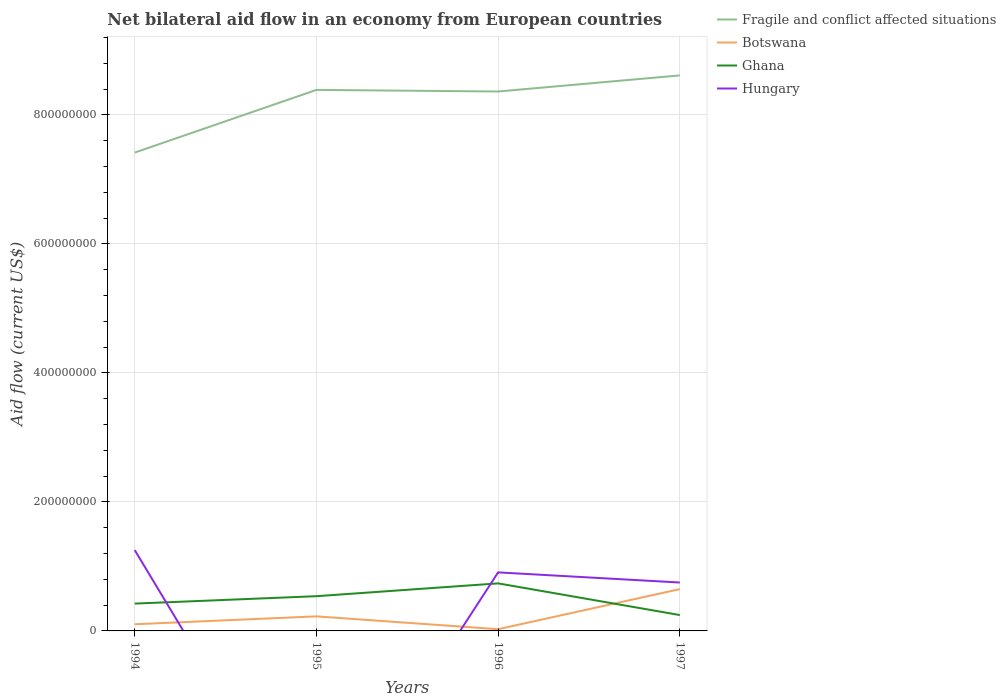How many different coloured lines are there?
Provide a short and direct response. 4. Across all years, what is the maximum net bilateral aid flow in Hungary?
Offer a very short reply. 0. What is the total net bilateral aid flow in Botswana in the graph?
Keep it short and to the point. -1.22e+07. What is the difference between the highest and the second highest net bilateral aid flow in Ghana?
Your response must be concise. 4.91e+07. What is the difference between the highest and the lowest net bilateral aid flow in Hungary?
Offer a very short reply. 3. Is the net bilateral aid flow in Ghana strictly greater than the net bilateral aid flow in Hungary over the years?
Offer a very short reply. No. How many years are there in the graph?
Give a very brief answer. 4. Are the values on the major ticks of Y-axis written in scientific E-notation?
Provide a succinct answer. No. Does the graph contain grids?
Keep it short and to the point. Yes. What is the title of the graph?
Your response must be concise. Net bilateral aid flow in an economy from European countries. Does "Peru" appear as one of the legend labels in the graph?
Make the answer very short. No. What is the label or title of the Y-axis?
Your response must be concise. Aid flow (current US$). What is the Aid flow (current US$) in Fragile and conflict affected situations in 1994?
Provide a succinct answer. 7.42e+08. What is the Aid flow (current US$) of Botswana in 1994?
Ensure brevity in your answer.  1.03e+07. What is the Aid flow (current US$) of Ghana in 1994?
Ensure brevity in your answer.  4.24e+07. What is the Aid flow (current US$) of Hungary in 1994?
Ensure brevity in your answer.  1.25e+08. What is the Aid flow (current US$) in Fragile and conflict affected situations in 1995?
Provide a succinct answer. 8.39e+08. What is the Aid flow (current US$) of Botswana in 1995?
Offer a very short reply. 2.26e+07. What is the Aid flow (current US$) in Ghana in 1995?
Your answer should be compact. 5.38e+07. What is the Aid flow (current US$) in Fragile and conflict affected situations in 1996?
Provide a short and direct response. 8.36e+08. What is the Aid flow (current US$) in Botswana in 1996?
Provide a succinct answer. 2.67e+06. What is the Aid flow (current US$) in Ghana in 1996?
Provide a short and direct response. 7.37e+07. What is the Aid flow (current US$) of Hungary in 1996?
Provide a short and direct response. 9.08e+07. What is the Aid flow (current US$) of Fragile and conflict affected situations in 1997?
Provide a succinct answer. 8.61e+08. What is the Aid flow (current US$) in Botswana in 1997?
Offer a terse response. 6.48e+07. What is the Aid flow (current US$) in Ghana in 1997?
Ensure brevity in your answer.  2.46e+07. What is the Aid flow (current US$) in Hungary in 1997?
Keep it short and to the point. 7.50e+07. Across all years, what is the maximum Aid flow (current US$) of Fragile and conflict affected situations?
Offer a very short reply. 8.61e+08. Across all years, what is the maximum Aid flow (current US$) in Botswana?
Provide a short and direct response. 6.48e+07. Across all years, what is the maximum Aid flow (current US$) of Ghana?
Provide a short and direct response. 7.37e+07. Across all years, what is the maximum Aid flow (current US$) in Hungary?
Offer a very short reply. 1.25e+08. Across all years, what is the minimum Aid flow (current US$) in Fragile and conflict affected situations?
Your answer should be very brief. 7.42e+08. Across all years, what is the minimum Aid flow (current US$) of Botswana?
Your answer should be compact. 2.67e+06. Across all years, what is the minimum Aid flow (current US$) in Ghana?
Your answer should be very brief. 2.46e+07. What is the total Aid flow (current US$) in Fragile and conflict affected situations in the graph?
Make the answer very short. 3.28e+09. What is the total Aid flow (current US$) of Botswana in the graph?
Your answer should be compact. 1.00e+08. What is the total Aid flow (current US$) of Ghana in the graph?
Provide a succinct answer. 1.94e+08. What is the total Aid flow (current US$) of Hungary in the graph?
Your answer should be very brief. 2.91e+08. What is the difference between the Aid flow (current US$) of Fragile and conflict affected situations in 1994 and that in 1995?
Keep it short and to the point. -9.72e+07. What is the difference between the Aid flow (current US$) in Botswana in 1994 and that in 1995?
Your response must be concise. -1.22e+07. What is the difference between the Aid flow (current US$) in Ghana in 1994 and that in 1995?
Offer a very short reply. -1.15e+07. What is the difference between the Aid flow (current US$) of Fragile and conflict affected situations in 1994 and that in 1996?
Provide a short and direct response. -9.47e+07. What is the difference between the Aid flow (current US$) in Botswana in 1994 and that in 1996?
Your answer should be compact. 7.67e+06. What is the difference between the Aid flow (current US$) of Ghana in 1994 and that in 1996?
Offer a very short reply. -3.13e+07. What is the difference between the Aid flow (current US$) of Hungary in 1994 and that in 1996?
Provide a short and direct response. 3.45e+07. What is the difference between the Aid flow (current US$) of Fragile and conflict affected situations in 1994 and that in 1997?
Offer a very short reply. -1.20e+08. What is the difference between the Aid flow (current US$) of Botswana in 1994 and that in 1997?
Your response must be concise. -5.44e+07. What is the difference between the Aid flow (current US$) in Ghana in 1994 and that in 1997?
Make the answer very short. 1.78e+07. What is the difference between the Aid flow (current US$) in Hungary in 1994 and that in 1997?
Your answer should be very brief. 5.02e+07. What is the difference between the Aid flow (current US$) of Fragile and conflict affected situations in 1995 and that in 1996?
Provide a short and direct response. 2.49e+06. What is the difference between the Aid flow (current US$) of Botswana in 1995 and that in 1996?
Provide a succinct answer. 1.99e+07. What is the difference between the Aid flow (current US$) in Ghana in 1995 and that in 1996?
Keep it short and to the point. -1.99e+07. What is the difference between the Aid flow (current US$) in Fragile and conflict affected situations in 1995 and that in 1997?
Offer a very short reply. -2.24e+07. What is the difference between the Aid flow (current US$) in Botswana in 1995 and that in 1997?
Offer a very short reply. -4.22e+07. What is the difference between the Aid flow (current US$) of Ghana in 1995 and that in 1997?
Your answer should be compact. 2.92e+07. What is the difference between the Aid flow (current US$) of Fragile and conflict affected situations in 1996 and that in 1997?
Provide a short and direct response. -2.49e+07. What is the difference between the Aid flow (current US$) in Botswana in 1996 and that in 1997?
Offer a terse response. -6.21e+07. What is the difference between the Aid flow (current US$) in Ghana in 1996 and that in 1997?
Offer a terse response. 4.91e+07. What is the difference between the Aid flow (current US$) in Hungary in 1996 and that in 1997?
Provide a short and direct response. 1.57e+07. What is the difference between the Aid flow (current US$) of Fragile and conflict affected situations in 1994 and the Aid flow (current US$) of Botswana in 1995?
Keep it short and to the point. 7.19e+08. What is the difference between the Aid flow (current US$) of Fragile and conflict affected situations in 1994 and the Aid flow (current US$) of Ghana in 1995?
Provide a short and direct response. 6.88e+08. What is the difference between the Aid flow (current US$) of Botswana in 1994 and the Aid flow (current US$) of Ghana in 1995?
Provide a short and direct response. -4.35e+07. What is the difference between the Aid flow (current US$) in Fragile and conflict affected situations in 1994 and the Aid flow (current US$) in Botswana in 1996?
Provide a succinct answer. 7.39e+08. What is the difference between the Aid flow (current US$) in Fragile and conflict affected situations in 1994 and the Aid flow (current US$) in Ghana in 1996?
Give a very brief answer. 6.68e+08. What is the difference between the Aid flow (current US$) of Fragile and conflict affected situations in 1994 and the Aid flow (current US$) of Hungary in 1996?
Provide a succinct answer. 6.51e+08. What is the difference between the Aid flow (current US$) of Botswana in 1994 and the Aid flow (current US$) of Ghana in 1996?
Provide a short and direct response. -6.34e+07. What is the difference between the Aid flow (current US$) of Botswana in 1994 and the Aid flow (current US$) of Hungary in 1996?
Ensure brevity in your answer.  -8.04e+07. What is the difference between the Aid flow (current US$) of Ghana in 1994 and the Aid flow (current US$) of Hungary in 1996?
Offer a very short reply. -4.84e+07. What is the difference between the Aid flow (current US$) of Fragile and conflict affected situations in 1994 and the Aid flow (current US$) of Botswana in 1997?
Give a very brief answer. 6.77e+08. What is the difference between the Aid flow (current US$) of Fragile and conflict affected situations in 1994 and the Aid flow (current US$) of Ghana in 1997?
Your response must be concise. 7.17e+08. What is the difference between the Aid flow (current US$) of Fragile and conflict affected situations in 1994 and the Aid flow (current US$) of Hungary in 1997?
Provide a short and direct response. 6.67e+08. What is the difference between the Aid flow (current US$) in Botswana in 1994 and the Aid flow (current US$) in Ghana in 1997?
Keep it short and to the point. -1.42e+07. What is the difference between the Aid flow (current US$) of Botswana in 1994 and the Aid flow (current US$) of Hungary in 1997?
Your answer should be compact. -6.47e+07. What is the difference between the Aid flow (current US$) in Ghana in 1994 and the Aid flow (current US$) in Hungary in 1997?
Offer a terse response. -3.27e+07. What is the difference between the Aid flow (current US$) in Fragile and conflict affected situations in 1995 and the Aid flow (current US$) in Botswana in 1996?
Ensure brevity in your answer.  8.36e+08. What is the difference between the Aid flow (current US$) in Fragile and conflict affected situations in 1995 and the Aid flow (current US$) in Ghana in 1996?
Offer a very short reply. 7.65e+08. What is the difference between the Aid flow (current US$) of Fragile and conflict affected situations in 1995 and the Aid flow (current US$) of Hungary in 1996?
Your response must be concise. 7.48e+08. What is the difference between the Aid flow (current US$) in Botswana in 1995 and the Aid flow (current US$) in Ghana in 1996?
Your response must be concise. -5.11e+07. What is the difference between the Aid flow (current US$) in Botswana in 1995 and the Aid flow (current US$) in Hungary in 1996?
Ensure brevity in your answer.  -6.82e+07. What is the difference between the Aid flow (current US$) of Ghana in 1995 and the Aid flow (current US$) of Hungary in 1996?
Your response must be concise. -3.69e+07. What is the difference between the Aid flow (current US$) of Fragile and conflict affected situations in 1995 and the Aid flow (current US$) of Botswana in 1997?
Make the answer very short. 7.74e+08. What is the difference between the Aid flow (current US$) of Fragile and conflict affected situations in 1995 and the Aid flow (current US$) of Ghana in 1997?
Provide a short and direct response. 8.14e+08. What is the difference between the Aid flow (current US$) in Fragile and conflict affected situations in 1995 and the Aid flow (current US$) in Hungary in 1997?
Offer a terse response. 7.64e+08. What is the difference between the Aid flow (current US$) of Botswana in 1995 and the Aid flow (current US$) of Ghana in 1997?
Ensure brevity in your answer.  -2.01e+06. What is the difference between the Aid flow (current US$) in Botswana in 1995 and the Aid flow (current US$) in Hungary in 1997?
Offer a very short reply. -5.25e+07. What is the difference between the Aid flow (current US$) in Ghana in 1995 and the Aid flow (current US$) in Hungary in 1997?
Offer a very short reply. -2.12e+07. What is the difference between the Aid flow (current US$) in Fragile and conflict affected situations in 1996 and the Aid flow (current US$) in Botswana in 1997?
Your answer should be compact. 7.71e+08. What is the difference between the Aid flow (current US$) in Fragile and conflict affected situations in 1996 and the Aid flow (current US$) in Ghana in 1997?
Offer a terse response. 8.12e+08. What is the difference between the Aid flow (current US$) of Fragile and conflict affected situations in 1996 and the Aid flow (current US$) of Hungary in 1997?
Offer a terse response. 7.61e+08. What is the difference between the Aid flow (current US$) of Botswana in 1996 and the Aid flow (current US$) of Ghana in 1997?
Keep it short and to the point. -2.19e+07. What is the difference between the Aid flow (current US$) of Botswana in 1996 and the Aid flow (current US$) of Hungary in 1997?
Offer a terse response. -7.24e+07. What is the difference between the Aid flow (current US$) of Ghana in 1996 and the Aid flow (current US$) of Hungary in 1997?
Ensure brevity in your answer.  -1.35e+06. What is the average Aid flow (current US$) in Fragile and conflict affected situations per year?
Offer a very short reply. 8.19e+08. What is the average Aid flow (current US$) of Botswana per year?
Make the answer very short. 2.51e+07. What is the average Aid flow (current US$) in Ghana per year?
Your response must be concise. 4.86e+07. What is the average Aid flow (current US$) of Hungary per year?
Your answer should be very brief. 7.28e+07. In the year 1994, what is the difference between the Aid flow (current US$) in Fragile and conflict affected situations and Aid flow (current US$) in Botswana?
Give a very brief answer. 7.31e+08. In the year 1994, what is the difference between the Aid flow (current US$) of Fragile and conflict affected situations and Aid flow (current US$) of Ghana?
Give a very brief answer. 6.99e+08. In the year 1994, what is the difference between the Aid flow (current US$) in Fragile and conflict affected situations and Aid flow (current US$) in Hungary?
Give a very brief answer. 6.16e+08. In the year 1994, what is the difference between the Aid flow (current US$) in Botswana and Aid flow (current US$) in Ghana?
Offer a terse response. -3.20e+07. In the year 1994, what is the difference between the Aid flow (current US$) of Botswana and Aid flow (current US$) of Hungary?
Ensure brevity in your answer.  -1.15e+08. In the year 1994, what is the difference between the Aid flow (current US$) of Ghana and Aid flow (current US$) of Hungary?
Offer a very short reply. -8.29e+07. In the year 1995, what is the difference between the Aid flow (current US$) in Fragile and conflict affected situations and Aid flow (current US$) in Botswana?
Your answer should be very brief. 8.16e+08. In the year 1995, what is the difference between the Aid flow (current US$) of Fragile and conflict affected situations and Aid flow (current US$) of Ghana?
Your answer should be very brief. 7.85e+08. In the year 1995, what is the difference between the Aid flow (current US$) in Botswana and Aid flow (current US$) in Ghana?
Offer a terse response. -3.13e+07. In the year 1996, what is the difference between the Aid flow (current US$) of Fragile and conflict affected situations and Aid flow (current US$) of Botswana?
Give a very brief answer. 8.34e+08. In the year 1996, what is the difference between the Aid flow (current US$) of Fragile and conflict affected situations and Aid flow (current US$) of Ghana?
Your answer should be very brief. 7.63e+08. In the year 1996, what is the difference between the Aid flow (current US$) of Fragile and conflict affected situations and Aid flow (current US$) of Hungary?
Your response must be concise. 7.45e+08. In the year 1996, what is the difference between the Aid flow (current US$) in Botswana and Aid flow (current US$) in Ghana?
Your response must be concise. -7.10e+07. In the year 1996, what is the difference between the Aid flow (current US$) in Botswana and Aid flow (current US$) in Hungary?
Your response must be concise. -8.81e+07. In the year 1996, what is the difference between the Aid flow (current US$) of Ghana and Aid flow (current US$) of Hungary?
Ensure brevity in your answer.  -1.70e+07. In the year 1997, what is the difference between the Aid flow (current US$) in Fragile and conflict affected situations and Aid flow (current US$) in Botswana?
Give a very brief answer. 7.96e+08. In the year 1997, what is the difference between the Aid flow (current US$) of Fragile and conflict affected situations and Aid flow (current US$) of Ghana?
Your response must be concise. 8.37e+08. In the year 1997, what is the difference between the Aid flow (current US$) of Fragile and conflict affected situations and Aid flow (current US$) of Hungary?
Keep it short and to the point. 7.86e+08. In the year 1997, what is the difference between the Aid flow (current US$) of Botswana and Aid flow (current US$) of Ghana?
Offer a terse response. 4.02e+07. In the year 1997, what is the difference between the Aid flow (current US$) in Botswana and Aid flow (current US$) in Hungary?
Provide a succinct answer. -1.03e+07. In the year 1997, what is the difference between the Aid flow (current US$) of Ghana and Aid flow (current US$) of Hungary?
Your answer should be compact. -5.05e+07. What is the ratio of the Aid flow (current US$) in Fragile and conflict affected situations in 1994 to that in 1995?
Make the answer very short. 0.88. What is the ratio of the Aid flow (current US$) in Botswana in 1994 to that in 1995?
Your answer should be very brief. 0.46. What is the ratio of the Aid flow (current US$) in Ghana in 1994 to that in 1995?
Make the answer very short. 0.79. What is the ratio of the Aid flow (current US$) of Fragile and conflict affected situations in 1994 to that in 1996?
Keep it short and to the point. 0.89. What is the ratio of the Aid flow (current US$) in Botswana in 1994 to that in 1996?
Make the answer very short. 3.87. What is the ratio of the Aid flow (current US$) of Ghana in 1994 to that in 1996?
Offer a very short reply. 0.57. What is the ratio of the Aid flow (current US$) in Hungary in 1994 to that in 1996?
Offer a terse response. 1.38. What is the ratio of the Aid flow (current US$) of Fragile and conflict affected situations in 1994 to that in 1997?
Provide a succinct answer. 0.86. What is the ratio of the Aid flow (current US$) of Botswana in 1994 to that in 1997?
Keep it short and to the point. 0.16. What is the ratio of the Aid flow (current US$) of Ghana in 1994 to that in 1997?
Offer a very short reply. 1.72. What is the ratio of the Aid flow (current US$) of Hungary in 1994 to that in 1997?
Ensure brevity in your answer.  1.67. What is the ratio of the Aid flow (current US$) of Fragile and conflict affected situations in 1995 to that in 1996?
Provide a succinct answer. 1. What is the ratio of the Aid flow (current US$) of Botswana in 1995 to that in 1996?
Ensure brevity in your answer.  8.46. What is the ratio of the Aid flow (current US$) in Ghana in 1995 to that in 1996?
Provide a short and direct response. 0.73. What is the ratio of the Aid flow (current US$) of Fragile and conflict affected situations in 1995 to that in 1997?
Your answer should be compact. 0.97. What is the ratio of the Aid flow (current US$) in Botswana in 1995 to that in 1997?
Offer a terse response. 0.35. What is the ratio of the Aid flow (current US$) of Ghana in 1995 to that in 1997?
Ensure brevity in your answer.  2.19. What is the ratio of the Aid flow (current US$) of Fragile and conflict affected situations in 1996 to that in 1997?
Your answer should be compact. 0.97. What is the ratio of the Aid flow (current US$) of Botswana in 1996 to that in 1997?
Make the answer very short. 0.04. What is the ratio of the Aid flow (current US$) in Ghana in 1996 to that in 1997?
Keep it short and to the point. 3. What is the ratio of the Aid flow (current US$) of Hungary in 1996 to that in 1997?
Your answer should be very brief. 1.21. What is the difference between the highest and the second highest Aid flow (current US$) in Fragile and conflict affected situations?
Your answer should be very brief. 2.24e+07. What is the difference between the highest and the second highest Aid flow (current US$) of Botswana?
Your answer should be very brief. 4.22e+07. What is the difference between the highest and the second highest Aid flow (current US$) in Ghana?
Your answer should be compact. 1.99e+07. What is the difference between the highest and the second highest Aid flow (current US$) in Hungary?
Your answer should be very brief. 3.45e+07. What is the difference between the highest and the lowest Aid flow (current US$) of Fragile and conflict affected situations?
Make the answer very short. 1.20e+08. What is the difference between the highest and the lowest Aid flow (current US$) of Botswana?
Offer a terse response. 6.21e+07. What is the difference between the highest and the lowest Aid flow (current US$) in Ghana?
Your answer should be very brief. 4.91e+07. What is the difference between the highest and the lowest Aid flow (current US$) in Hungary?
Your response must be concise. 1.25e+08. 